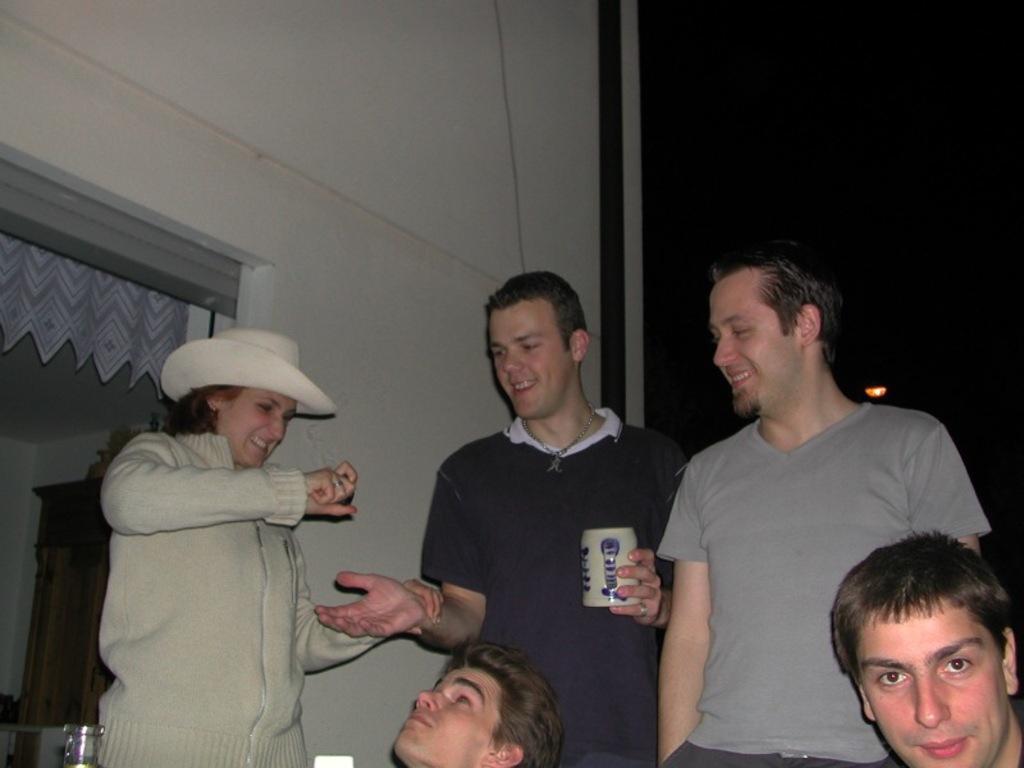Describe this image in one or two sentences. In this image there are five persons, in which three persons are standing, and in the background there is a wall and some other items. 